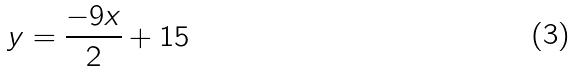Convert formula to latex. <formula><loc_0><loc_0><loc_500><loc_500>y = \frac { - 9 x } { 2 } + 1 5</formula> 